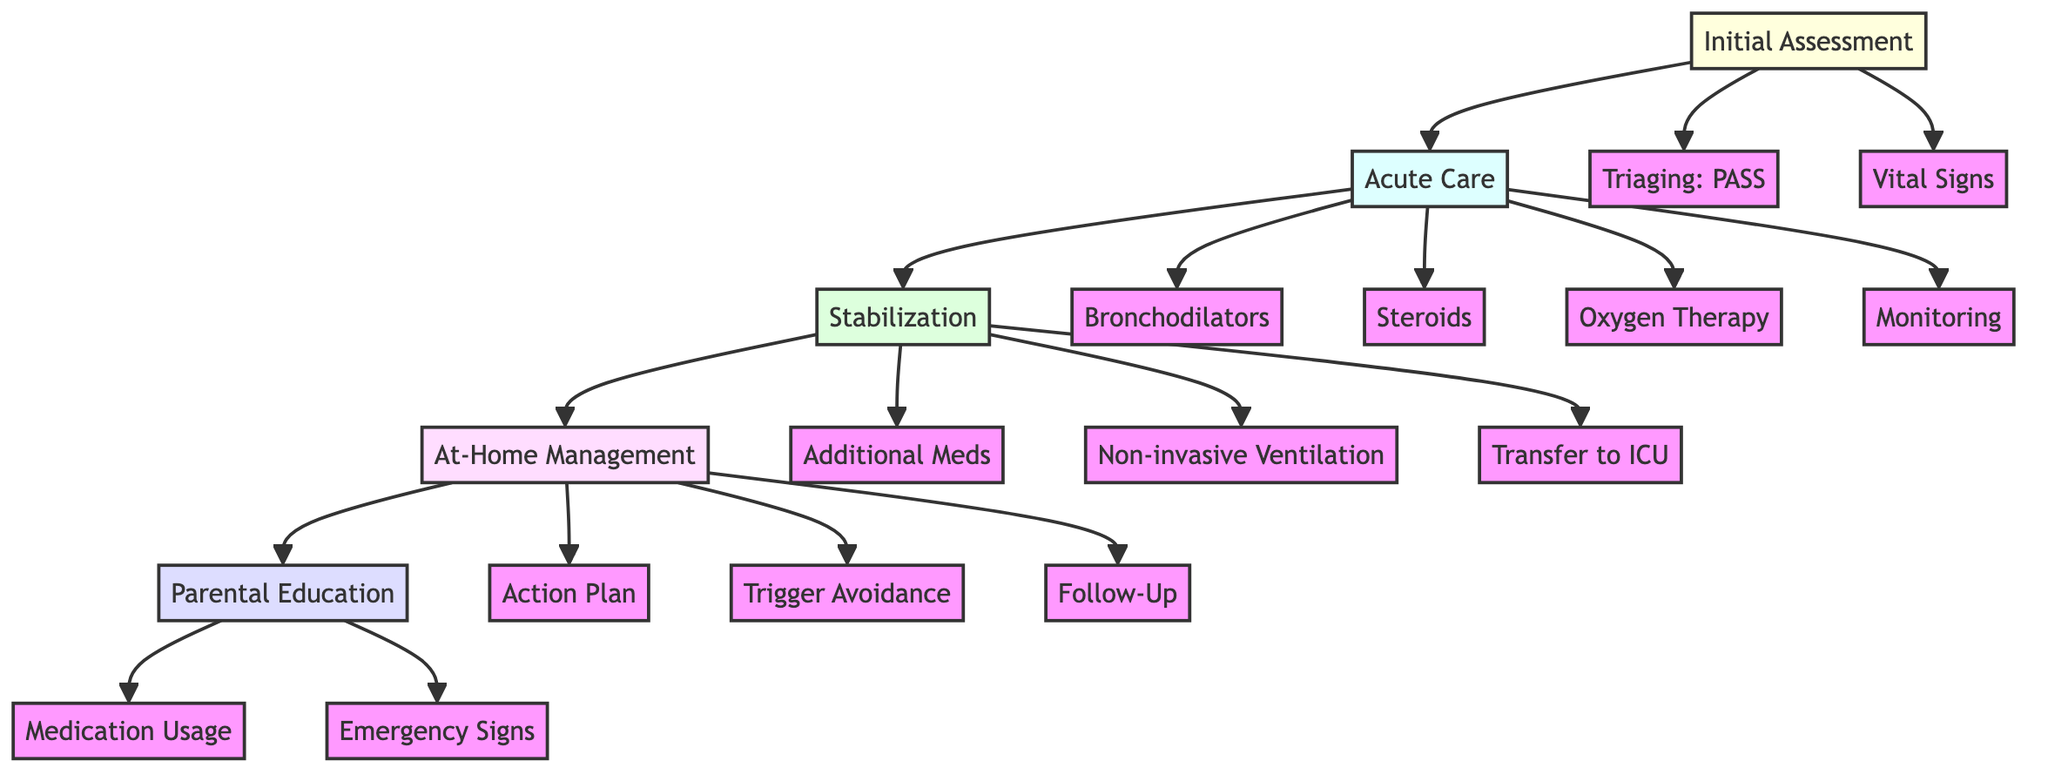What is the first step in the clinical pathway? The first step is 'Initial Assessment', as indicated at the top of the diagram. This step begins the process of handling severe asthma exacerbations in children.
Answer: Initial Assessment How many main sections are in the clinical pathway? There are five main sections: Initial Assessment, Acute Care, Stabilization, At-Home Management, and Parental Education. This can be counted directly from the nodes in the diagram.
Answer: Five What medication is administered via nebulizer? The diagram specifies that 'Albuterol' is the medication administered via nebulizer in the Acute Care section under Bronchodilators.
Answer: Albuterol What action is taken if a child's oxygen saturation is below 92%? The diagram states that 'Provide supplemental oxygen' is the action taken if the O2 saturation is below 92%, a part of the Acute Care section.
Answer: Provide supplemental oxygen What is the purpose of the action plan in at-home management? The diagram indicates that the purpose of the action plan is to create a 'personalized asthma management plan', which includes daily medications and emergency steps.
Answer: Personalized asthma management plan Which section addresses recognition of emergency signs? The section that addresses this is 'Parental Education', specifically the subsection for 'Emergency Signs'. This is focused on educating caregivers.
Answer: Parental Education If there is no improvement within 1-2 hours, what should be done? The clinical pathway states that 'Initiate transfer to ICU' should be done in the Stabilization section if there is no improvement in the child’s condition.
Answer: Initiate transfer to ICU Which medications are considered for severe cases in stabilization? According to the diagram, 'magnesium sulfate IV' is considered as an additional medication for severe cases in the Stabilization section.
Answer: Magnesium sulfate IV What are the vital signs that need to be monitored? The vital signs to be monitored include 'oxygen saturation, respiratory rate, and heart rate', listed in the Initial Assessment section.
Answer: Oxygen saturation, respiratory rate, and heart rate 